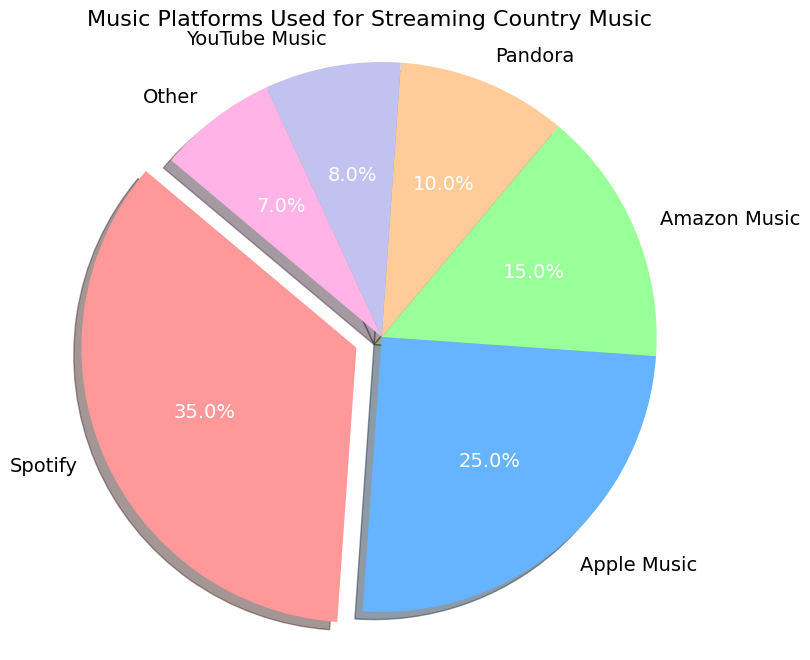Which music platform has the highest percentage for streaming country music? The pie chart shows that Spotify's slice is larger and exploded, indicating it has the highest percentage among the platforms.
Answer: Spotify Compare the percentages of Apple Music and Amazon Music for streaming country music. Which is higher? From the pie chart, the section representing Apple Music is larger than the section representing Amazon Music. Therefore, Apple Music has a higher percentage.
Answer: Apple Music How much larger is Spotify's percentage compared to Pandora's percentage for streaming country music? Spotify has a percentage of 35%, and Pandora has a percentage of 10%. The difference between them is 35% - 10% = 25%.
Answer: 25% What percentage of users use platforms other than Spotify, Apple Music, and Amazon Music for streaming country music? From the chart, the percentages for platforms other than Spotify, Apple Music, and Amazon Music are Pandora (10%), YouTube Music (8%), and Other (7%). Summing these gives 10% + 8% + 7% = 25%.
Answer: 25% What is the ratio of the percentage of Spotify users to the percentage of YouTube Music users for streaming country music? According to the chart, Spotify has a percentage of 35% and YouTube Music has a percentage of 8%. The ratio is 35% / 8% = 4.375.
Answer: 4.375 If the total percentage of the pie chart must be 100%, how much more percentage is required to fulfill this condition with the current sum of the given percentages? From the chart, the sum of all given percentages is 35% + 25% + 15% + 10% + 8% + 7% = 100%. Since the total percentage equates to 100%, no additional percentage is required.
Answer: 0% Which music platform, among those with less than 10% usage, has the lowest percentage for streaming country music? The platforms with less than 10% usage are Pandora (10%), YouTube Music (8%), and Other (7%). Among these, 'Other' has the lowest percentage.
Answer: Other Determine the total percentage for platforms Apple Music and Pandora combined for streaming country music. Apple Music has a percentage of 25%, and Pandora has a percentage of 10%. Combined, they account for 25% + 10% = 35%.
Answer: 35% What color is the section representing Amazon Music in the pie chart? According to the provided code, the color for Amazon Music is green.
Answer: Green 